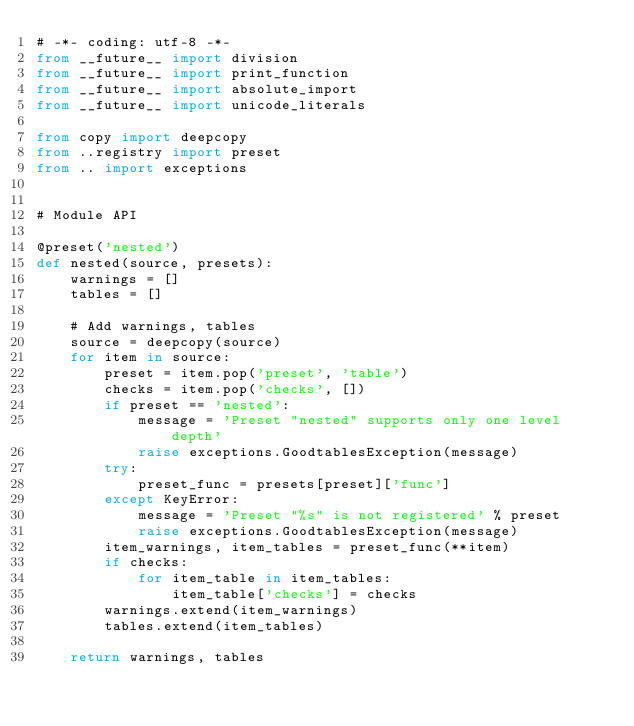Convert code to text. <code><loc_0><loc_0><loc_500><loc_500><_Python_># -*- coding: utf-8 -*-
from __future__ import division
from __future__ import print_function
from __future__ import absolute_import
from __future__ import unicode_literals

from copy import deepcopy
from ..registry import preset
from .. import exceptions


# Module API

@preset('nested')
def nested(source, presets):
    warnings = []
    tables = []

    # Add warnings, tables
    source = deepcopy(source)
    for item in source:
        preset = item.pop('preset', 'table')
        checks = item.pop('checks', [])
        if preset == 'nested':
            message = 'Preset "nested" supports only one level depth'
            raise exceptions.GoodtablesException(message)
        try:
            preset_func = presets[preset]['func']
        except KeyError:
            message = 'Preset "%s" is not registered' % preset
            raise exceptions.GoodtablesException(message)
        item_warnings, item_tables = preset_func(**item)
        if checks:
            for item_table in item_tables:
                item_table['checks'] = checks
        warnings.extend(item_warnings)
        tables.extend(item_tables)

    return warnings, tables
</code> 